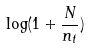Convert formula to latex. <formula><loc_0><loc_0><loc_500><loc_500>\log ( 1 + \frac { N } { n _ { t } } )</formula> 